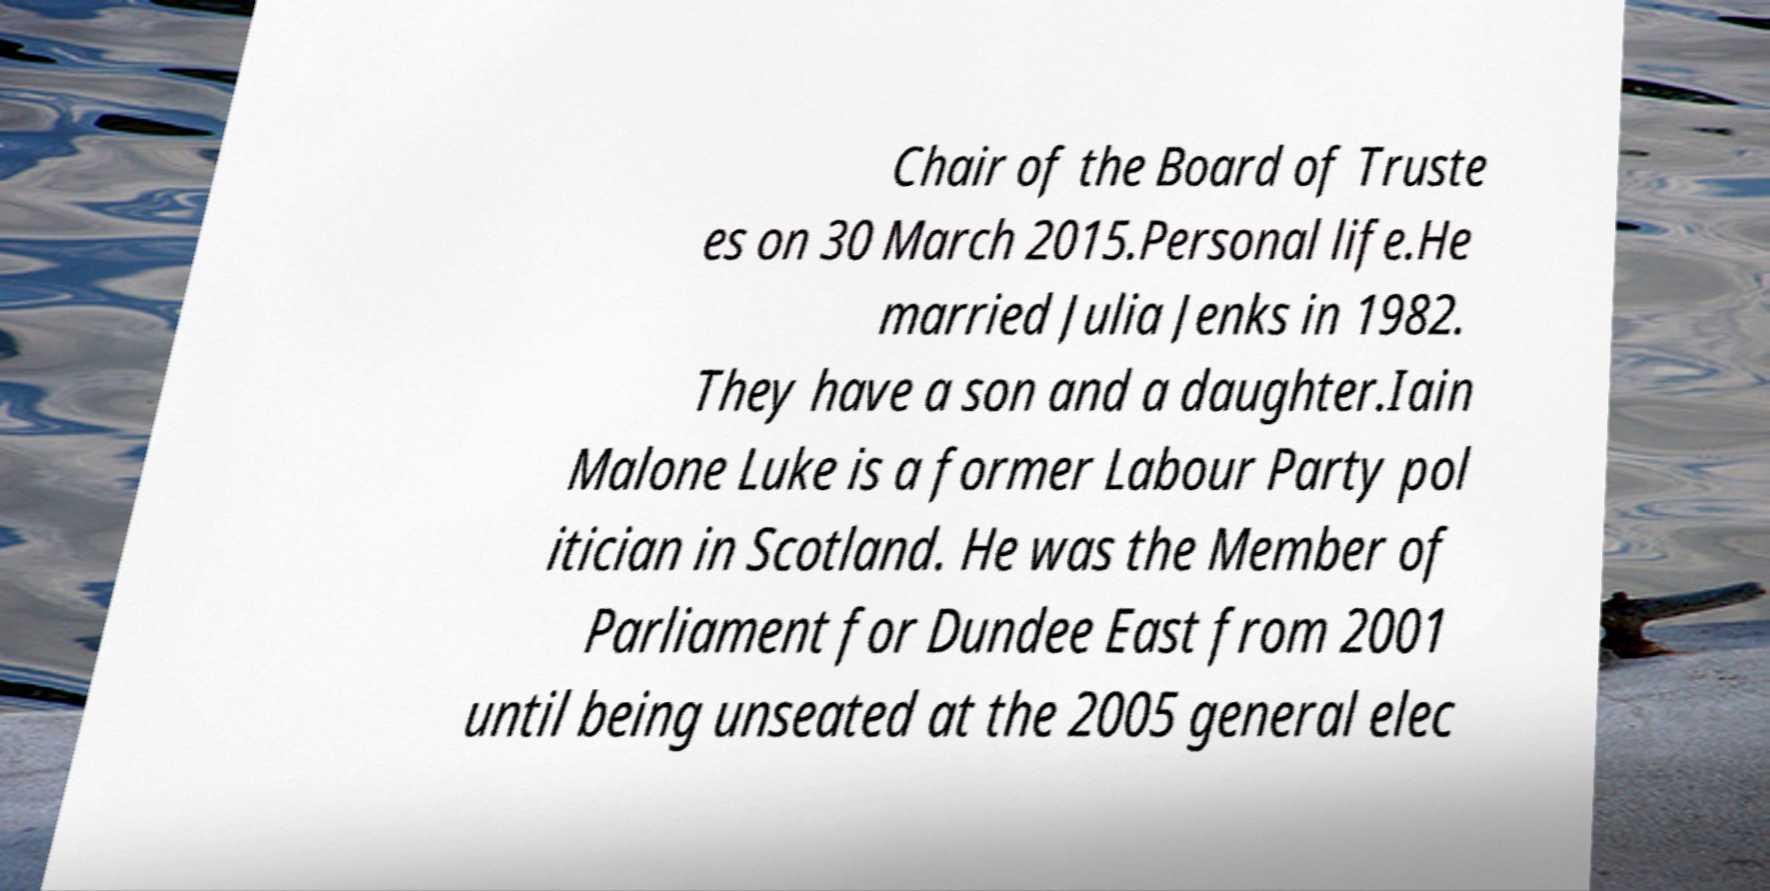Can you read and provide the text displayed in the image?This photo seems to have some interesting text. Can you extract and type it out for me? Chair of the Board of Truste es on 30 March 2015.Personal life.He married Julia Jenks in 1982. They have a son and a daughter.Iain Malone Luke is a former Labour Party pol itician in Scotland. He was the Member of Parliament for Dundee East from 2001 until being unseated at the 2005 general elec 